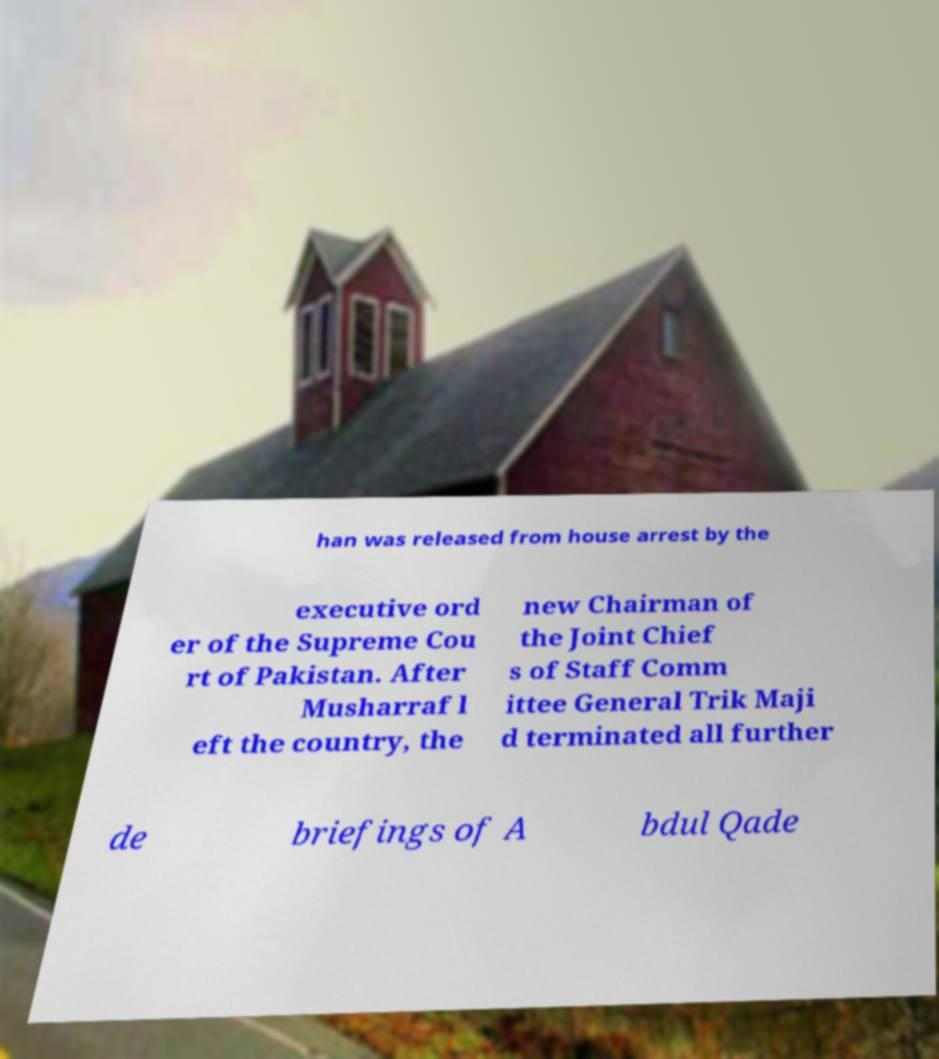Could you extract and type out the text from this image? han was released from house arrest by the executive ord er of the Supreme Cou rt of Pakistan. After Musharraf l eft the country, the new Chairman of the Joint Chief s of Staff Comm ittee General Trik Maji d terminated all further de briefings of A bdul Qade 